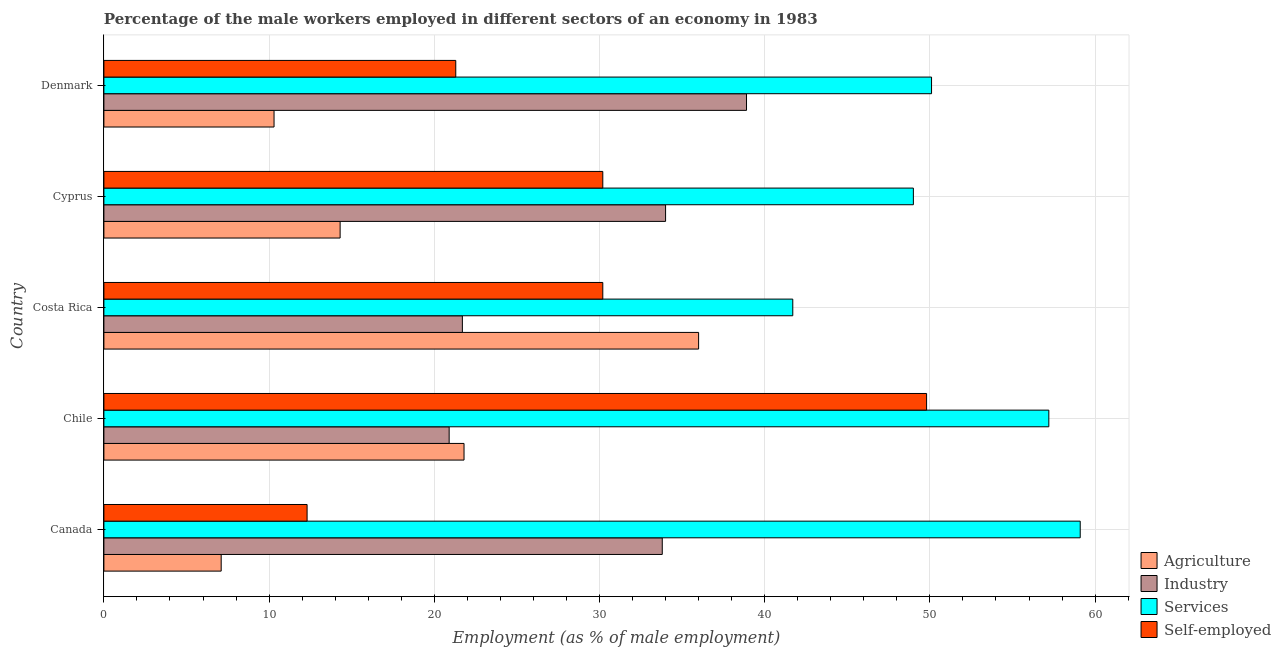How many different coloured bars are there?
Offer a terse response. 4. How many groups of bars are there?
Your answer should be compact. 5. Are the number of bars on each tick of the Y-axis equal?
Provide a short and direct response. Yes. How many bars are there on the 2nd tick from the bottom?
Provide a short and direct response. 4. What is the label of the 3rd group of bars from the top?
Offer a very short reply. Costa Rica. In how many cases, is the number of bars for a given country not equal to the number of legend labels?
Ensure brevity in your answer.  0. What is the percentage of male workers in industry in Chile?
Provide a short and direct response. 20.9. Across all countries, what is the maximum percentage of male workers in industry?
Offer a very short reply. 38.9. Across all countries, what is the minimum percentage of male workers in industry?
Offer a very short reply. 20.9. In which country was the percentage of male workers in industry minimum?
Your answer should be very brief. Chile. What is the total percentage of male workers in industry in the graph?
Provide a short and direct response. 149.3. What is the difference between the percentage of male workers in services in Costa Rica and that in Cyprus?
Keep it short and to the point. -7.3. What is the difference between the percentage of male workers in industry in Cyprus and the percentage of male workers in agriculture in Denmark?
Your answer should be very brief. 23.7. What is the average percentage of male workers in industry per country?
Offer a very short reply. 29.86. What is the difference between the percentage of male workers in industry and percentage of male workers in agriculture in Cyprus?
Offer a terse response. 19.7. In how many countries, is the percentage of male workers in agriculture greater than 4 %?
Provide a succinct answer. 5. What is the ratio of the percentage of male workers in services in Canada to that in Cyprus?
Offer a very short reply. 1.21. Is the percentage of male workers in agriculture in Canada less than that in Chile?
Offer a terse response. Yes. Is the difference between the percentage of self employed male workers in Costa Rica and Cyprus greater than the difference between the percentage of male workers in services in Costa Rica and Cyprus?
Offer a terse response. Yes. What is the difference between the highest and the lowest percentage of male workers in agriculture?
Give a very brief answer. 28.9. What does the 3rd bar from the top in Canada represents?
Your answer should be very brief. Industry. What does the 4th bar from the bottom in Cyprus represents?
Provide a succinct answer. Self-employed. Are all the bars in the graph horizontal?
Your answer should be very brief. Yes. What is the difference between two consecutive major ticks on the X-axis?
Provide a short and direct response. 10. Does the graph contain any zero values?
Your answer should be very brief. No. Where does the legend appear in the graph?
Keep it short and to the point. Bottom right. What is the title of the graph?
Your answer should be compact. Percentage of the male workers employed in different sectors of an economy in 1983. What is the label or title of the X-axis?
Your answer should be compact. Employment (as % of male employment). What is the Employment (as % of male employment) of Agriculture in Canada?
Provide a short and direct response. 7.1. What is the Employment (as % of male employment) of Industry in Canada?
Your response must be concise. 33.8. What is the Employment (as % of male employment) in Services in Canada?
Provide a succinct answer. 59.1. What is the Employment (as % of male employment) in Self-employed in Canada?
Keep it short and to the point. 12.3. What is the Employment (as % of male employment) of Agriculture in Chile?
Make the answer very short. 21.8. What is the Employment (as % of male employment) in Industry in Chile?
Offer a terse response. 20.9. What is the Employment (as % of male employment) of Services in Chile?
Your answer should be compact. 57.2. What is the Employment (as % of male employment) of Self-employed in Chile?
Your answer should be very brief. 49.8. What is the Employment (as % of male employment) in Agriculture in Costa Rica?
Your response must be concise. 36. What is the Employment (as % of male employment) in Industry in Costa Rica?
Your answer should be compact. 21.7. What is the Employment (as % of male employment) of Services in Costa Rica?
Ensure brevity in your answer.  41.7. What is the Employment (as % of male employment) of Self-employed in Costa Rica?
Your answer should be compact. 30.2. What is the Employment (as % of male employment) of Agriculture in Cyprus?
Your response must be concise. 14.3. What is the Employment (as % of male employment) in Industry in Cyprus?
Your answer should be compact. 34. What is the Employment (as % of male employment) of Services in Cyprus?
Your answer should be compact. 49. What is the Employment (as % of male employment) in Self-employed in Cyprus?
Provide a short and direct response. 30.2. What is the Employment (as % of male employment) in Agriculture in Denmark?
Keep it short and to the point. 10.3. What is the Employment (as % of male employment) in Industry in Denmark?
Your response must be concise. 38.9. What is the Employment (as % of male employment) in Services in Denmark?
Your answer should be compact. 50.1. What is the Employment (as % of male employment) in Self-employed in Denmark?
Your answer should be compact. 21.3. Across all countries, what is the maximum Employment (as % of male employment) in Agriculture?
Give a very brief answer. 36. Across all countries, what is the maximum Employment (as % of male employment) of Industry?
Ensure brevity in your answer.  38.9. Across all countries, what is the maximum Employment (as % of male employment) of Services?
Give a very brief answer. 59.1. Across all countries, what is the maximum Employment (as % of male employment) of Self-employed?
Offer a very short reply. 49.8. Across all countries, what is the minimum Employment (as % of male employment) of Agriculture?
Offer a very short reply. 7.1. Across all countries, what is the minimum Employment (as % of male employment) of Industry?
Provide a succinct answer. 20.9. Across all countries, what is the minimum Employment (as % of male employment) in Services?
Keep it short and to the point. 41.7. Across all countries, what is the minimum Employment (as % of male employment) of Self-employed?
Offer a terse response. 12.3. What is the total Employment (as % of male employment) of Agriculture in the graph?
Your answer should be compact. 89.5. What is the total Employment (as % of male employment) in Industry in the graph?
Provide a short and direct response. 149.3. What is the total Employment (as % of male employment) in Services in the graph?
Give a very brief answer. 257.1. What is the total Employment (as % of male employment) in Self-employed in the graph?
Make the answer very short. 143.8. What is the difference between the Employment (as % of male employment) of Agriculture in Canada and that in Chile?
Offer a terse response. -14.7. What is the difference between the Employment (as % of male employment) of Industry in Canada and that in Chile?
Offer a terse response. 12.9. What is the difference between the Employment (as % of male employment) in Services in Canada and that in Chile?
Offer a terse response. 1.9. What is the difference between the Employment (as % of male employment) in Self-employed in Canada and that in Chile?
Your answer should be very brief. -37.5. What is the difference between the Employment (as % of male employment) in Agriculture in Canada and that in Costa Rica?
Offer a very short reply. -28.9. What is the difference between the Employment (as % of male employment) of Industry in Canada and that in Costa Rica?
Make the answer very short. 12.1. What is the difference between the Employment (as % of male employment) in Self-employed in Canada and that in Costa Rica?
Make the answer very short. -17.9. What is the difference between the Employment (as % of male employment) of Agriculture in Canada and that in Cyprus?
Give a very brief answer. -7.2. What is the difference between the Employment (as % of male employment) in Services in Canada and that in Cyprus?
Your answer should be compact. 10.1. What is the difference between the Employment (as % of male employment) in Self-employed in Canada and that in Cyprus?
Your response must be concise. -17.9. What is the difference between the Employment (as % of male employment) in Agriculture in Canada and that in Denmark?
Your answer should be compact. -3.2. What is the difference between the Employment (as % of male employment) in Industry in Canada and that in Denmark?
Provide a succinct answer. -5.1. What is the difference between the Employment (as % of male employment) of Services in Canada and that in Denmark?
Offer a terse response. 9. What is the difference between the Employment (as % of male employment) of Self-employed in Canada and that in Denmark?
Your answer should be compact. -9. What is the difference between the Employment (as % of male employment) in Agriculture in Chile and that in Costa Rica?
Offer a terse response. -14.2. What is the difference between the Employment (as % of male employment) of Industry in Chile and that in Costa Rica?
Your answer should be compact. -0.8. What is the difference between the Employment (as % of male employment) of Services in Chile and that in Costa Rica?
Offer a very short reply. 15.5. What is the difference between the Employment (as % of male employment) of Self-employed in Chile and that in Costa Rica?
Give a very brief answer. 19.6. What is the difference between the Employment (as % of male employment) of Agriculture in Chile and that in Cyprus?
Your answer should be compact. 7.5. What is the difference between the Employment (as % of male employment) of Industry in Chile and that in Cyprus?
Offer a terse response. -13.1. What is the difference between the Employment (as % of male employment) in Self-employed in Chile and that in Cyprus?
Your answer should be compact. 19.6. What is the difference between the Employment (as % of male employment) in Agriculture in Chile and that in Denmark?
Ensure brevity in your answer.  11.5. What is the difference between the Employment (as % of male employment) in Services in Chile and that in Denmark?
Your response must be concise. 7.1. What is the difference between the Employment (as % of male employment) of Self-employed in Chile and that in Denmark?
Keep it short and to the point. 28.5. What is the difference between the Employment (as % of male employment) of Agriculture in Costa Rica and that in Cyprus?
Provide a short and direct response. 21.7. What is the difference between the Employment (as % of male employment) of Industry in Costa Rica and that in Cyprus?
Offer a very short reply. -12.3. What is the difference between the Employment (as % of male employment) in Services in Costa Rica and that in Cyprus?
Keep it short and to the point. -7.3. What is the difference between the Employment (as % of male employment) of Agriculture in Costa Rica and that in Denmark?
Offer a terse response. 25.7. What is the difference between the Employment (as % of male employment) in Industry in Costa Rica and that in Denmark?
Keep it short and to the point. -17.2. What is the difference between the Employment (as % of male employment) of Services in Costa Rica and that in Denmark?
Your response must be concise. -8.4. What is the difference between the Employment (as % of male employment) of Industry in Cyprus and that in Denmark?
Your answer should be very brief. -4.9. What is the difference between the Employment (as % of male employment) in Services in Cyprus and that in Denmark?
Your answer should be compact. -1.1. What is the difference between the Employment (as % of male employment) in Self-employed in Cyprus and that in Denmark?
Your answer should be very brief. 8.9. What is the difference between the Employment (as % of male employment) in Agriculture in Canada and the Employment (as % of male employment) in Services in Chile?
Your response must be concise. -50.1. What is the difference between the Employment (as % of male employment) in Agriculture in Canada and the Employment (as % of male employment) in Self-employed in Chile?
Your response must be concise. -42.7. What is the difference between the Employment (as % of male employment) in Industry in Canada and the Employment (as % of male employment) in Services in Chile?
Give a very brief answer. -23.4. What is the difference between the Employment (as % of male employment) in Industry in Canada and the Employment (as % of male employment) in Self-employed in Chile?
Your response must be concise. -16. What is the difference between the Employment (as % of male employment) in Agriculture in Canada and the Employment (as % of male employment) in Industry in Costa Rica?
Offer a very short reply. -14.6. What is the difference between the Employment (as % of male employment) in Agriculture in Canada and the Employment (as % of male employment) in Services in Costa Rica?
Your answer should be very brief. -34.6. What is the difference between the Employment (as % of male employment) in Agriculture in Canada and the Employment (as % of male employment) in Self-employed in Costa Rica?
Your answer should be compact. -23.1. What is the difference between the Employment (as % of male employment) of Services in Canada and the Employment (as % of male employment) of Self-employed in Costa Rica?
Ensure brevity in your answer.  28.9. What is the difference between the Employment (as % of male employment) of Agriculture in Canada and the Employment (as % of male employment) of Industry in Cyprus?
Give a very brief answer. -26.9. What is the difference between the Employment (as % of male employment) of Agriculture in Canada and the Employment (as % of male employment) of Services in Cyprus?
Provide a succinct answer. -41.9. What is the difference between the Employment (as % of male employment) of Agriculture in Canada and the Employment (as % of male employment) of Self-employed in Cyprus?
Your response must be concise. -23.1. What is the difference between the Employment (as % of male employment) of Industry in Canada and the Employment (as % of male employment) of Services in Cyprus?
Offer a very short reply. -15.2. What is the difference between the Employment (as % of male employment) in Industry in Canada and the Employment (as % of male employment) in Self-employed in Cyprus?
Offer a terse response. 3.6. What is the difference between the Employment (as % of male employment) in Services in Canada and the Employment (as % of male employment) in Self-employed in Cyprus?
Your response must be concise. 28.9. What is the difference between the Employment (as % of male employment) in Agriculture in Canada and the Employment (as % of male employment) in Industry in Denmark?
Your answer should be very brief. -31.8. What is the difference between the Employment (as % of male employment) of Agriculture in Canada and the Employment (as % of male employment) of Services in Denmark?
Ensure brevity in your answer.  -43. What is the difference between the Employment (as % of male employment) of Agriculture in Canada and the Employment (as % of male employment) of Self-employed in Denmark?
Ensure brevity in your answer.  -14.2. What is the difference between the Employment (as % of male employment) in Industry in Canada and the Employment (as % of male employment) in Services in Denmark?
Your answer should be very brief. -16.3. What is the difference between the Employment (as % of male employment) of Industry in Canada and the Employment (as % of male employment) of Self-employed in Denmark?
Provide a short and direct response. 12.5. What is the difference between the Employment (as % of male employment) in Services in Canada and the Employment (as % of male employment) in Self-employed in Denmark?
Provide a short and direct response. 37.8. What is the difference between the Employment (as % of male employment) in Agriculture in Chile and the Employment (as % of male employment) in Services in Costa Rica?
Your answer should be very brief. -19.9. What is the difference between the Employment (as % of male employment) of Industry in Chile and the Employment (as % of male employment) of Services in Costa Rica?
Give a very brief answer. -20.8. What is the difference between the Employment (as % of male employment) of Agriculture in Chile and the Employment (as % of male employment) of Services in Cyprus?
Your response must be concise. -27.2. What is the difference between the Employment (as % of male employment) in Industry in Chile and the Employment (as % of male employment) in Services in Cyprus?
Your answer should be compact. -28.1. What is the difference between the Employment (as % of male employment) in Industry in Chile and the Employment (as % of male employment) in Self-employed in Cyprus?
Offer a terse response. -9.3. What is the difference between the Employment (as % of male employment) in Agriculture in Chile and the Employment (as % of male employment) in Industry in Denmark?
Provide a succinct answer. -17.1. What is the difference between the Employment (as % of male employment) in Agriculture in Chile and the Employment (as % of male employment) in Services in Denmark?
Your answer should be compact. -28.3. What is the difference between the Employment (as % of male employment) in Industry in Chile and the Employment (as % of male employment) in Services in Denmark?
Offer a very short reply. -29.2. What is the difference between the Employment (as % of male employment) of Services in Chile and the Employment (as % of male employment) of Self-employed in Denmark?
Ensure brevity in your answer.  35.9. What is the difference between the Employment (as % of male employment) of Agriculture in Costa Rica and the Employment (as % of male employment) of Industry in Cyprus?
Your answer should be compact. 2. What is the difference between the Employment (as % of male employment) in Agriculture in Costa Rica and the Employment (as % of male employment) in Self-employed in Cyprus?
Keep it short and to the point. 5.8. What is the difference between the Employment (as % of male employment) in Industry in Costa Rica and the Employment (as % of male employment) in Services in Cyprus?
Your answer should be compact. -27.3. What is the difference between the Employment (as % of male employment) in Agriculture in Costa Rica and the Employment (as % of male employment) in Services in Denmark?
Give a very brief answer. -14.1. What is the difference between the Employment (as % of male employment) in Agriculture in Costa Rica and the Employment (as % of male employment) in Self-employed in Denmark?
Ensure brevity in your answer.  14.7. What is the difference between the Employment (as % of male employment) in Industry in Costa Rica and the Employment (as % of male employment) in Services in Denmark?
Give a very brief answer. -28.4. What is the difference between the Employment (as % of male employment) of Industry in Costa Rica and the Employment (as % of male employment) of Self-employed in Denmark?
Provide a succinct answer. 0.4. What is the difference between the Employment (as % of male employment) of Services in Costa Rica and the Employment (as % of male employment) of Self-employed in Denmark?
Make the answer very short. 20.4. What is the difference between the Employment (as % of male employment) of Agriculture in Cyprus and the Employment (as % of male employment) of Industry in Denmark?
Keep it short and to the point. -24.6. What is the difference between the Employment (as % of male employment) of Agriculture in Cyprus and the Employment (as % of male employment) of Services in Denmark?
Offer a terse response. -35.8. What is the difference between the Employment (as % of male employment) of Industry in Cyprus and the Employment (as % of male employment) of Services in Denmark?
Your answer should be compact. -16.1. What is the difference between the Employment (as % of male employment) in Services in Cyprus and the Employment (as % of male employment) in Self-employed in Denmark?
Provide a succinct answer. 27.7. What is the average Employment (as % of male employment) in Industry per country?
Make the answer very short. 29.86. What is the average Employment (as % of male employment) in Services per country?
Provide a succinct answer. 51.42. What is the average Employment (as % of male employment) in Self-employed per country?
Give a very brief answer. 28.76. What is the difference between the Employment (as % of male employment) of Agriculture and Employment (as % of male employment) of Industry in Canada?
Provide a short and direct response. -26.7. What is the difference between the Employment (as % of male employment) in Agriculture and Employment (as % of male employment) in Services in Canada?
Offer a terse response. -52. What is the difference between the Employment (as % of male employment) of Industry and Employment (as % of male employment) of Services in Canada?
Offer a terse response. -25.3. What is the difference between the Employment (as % of male employment) of Industry and Employment (as % of male employment) of Self-employed in Canada?
Give a very brief answer. 21.5. What is the difference between the Employment (as % of male employment) of Services and Employment (as % of male employment) of Self-employed in Canada?
Your response must be concise. 46.8. What is the difference between the Employment (as % of male employment) in Agriculture and Employment (as % of male employment) in Services in Chile?
Provide a short and direct response. -35.4. What is the difference between the Employment (as % of male employment) in Agriculture and Employment (as % of male employment) in Self-employed in Chile?
Make the answer very short. -28. What is the difference between the Employment (as % of male employment) in Industry and Employment (as % of male employment) in Services in Chile?
Give a very brief answer. -36.3. What is the difference between the Employment (as % of male employment) in Industry and Employment (as % of male employment) in Self-employed in Chile?
Your answer should be very brief. -28.9. What is the difference between the Employment (as % of male employment) of Services and Employment (as % of male employment) of Self-employed in Chile?
Your answer should be compact. 7.4. What is the difference between the Employment (as % of male employment) in Agriculture and Employment (as % of male employment) in Services in Costa Rica?
Offer a terse response. -5.7. What is the difference between the Employment (as % of male employment) in Agriculture and Employment (as % of male employment) in Self-employed in Costa Rica?
Your response must be concise. 5.8. What is the difference between the Employment (as % of male employment) in Industry and Employment (as % of male employment) in Services in Costa Rica?
Offer a terse response. -20. What is the difference between the Employment (as % of male employment) of Industry and Employment (as % of male employment) of Self-employed in Costa Rica?
Your answer should be compact. -8.5. What is the difference between the Employment (as % of male employment) in Services and Employment (as % of male employment) in Self-employed in Costa Rica?
Offer a terse response. 11.5. What is the difference between the Employment (as % of male employment) of Agriculture and Employment (as % of male employment) of Industry in Cyprus?
Offer a terse response. -19.7. What is the difference between the Employment (as % of male employment) in Agriculture and Employment (as % of male employment) in Services in Cyprus?
Your answer should be compact. -34.7. What is the difference between the Employment (as % of male employment) of Agriculture and Employment (as % of male employment) of Self-employed in Cyprus?
Your answer should be compact. -15.9. What is the difference between the Employment (as % of male employment) in Agriculture and Employment (as % of male employment) in Industry in Denmark?
Give a very brief answer. -28.6. What is the difference between the Employment (as % of male employment) of Agriculture and Employment (as % of male employment) of Services in Denmark?
Your answer should be very brief. -39.8. What is the difference between the Employment (as % of male employment) of Industry and Employment (as % of male employment) of Services in Denmark?
Keep it short and to the point. -11.2. What is the difference between the Employment (as % of male employment) of Industry and Employment (as % of male employment) of Self-employed in Denmark?
Offer a terse response. 17.6. What is the difference between the Employment (as % of male employment) of Services and Employment (as % of male employment) of Self-employed in Denmark?
Your answer should be compact. 28.8. What is the ratio of the Employment (as % of male employment) in Agriculture in Canada to that in Chile?
Your response must be concise. 0.33. What is the ratio of the Employment (as % of male employment) of Industry in Canada to that in Chile?
Give a very brief answer. 1.62. What is the ratio of the Employment (as % of male employment) in Services in Canada to that in Chile?
Provide a succinct answer. 1.03. What is the ratio of the Employment (as % of male employment) in Self-employed in Canada to that in Chile?
Ensure brevity in your answer.  0.25. What is the ratio of the Employment (as % of male employment) in Agriculture in Canada to that in Costa Rica?
Provide a short and direct response. 0.2. What is the ratio of the Employment (as % of male employment) in Industry in Canada to that in Costa Rica?
Provide a succinct answer. 1.56. What is the ratio of the Employment (as % of male employment) of Services in Canada to that in Costa Rica?
Provide a short and direct response. 1.42. What is the ratio of the Employment (as % of male employment) in Self-employed in Canada to that in Costa Rica?
Offer a very short reply. 0.41. What is the ratio of the Employment (as % of male employment) of Agriculture in Canada to that in Cyprus?
Your answer should be very brief. 0.5. What is the ratio of the Employment (as % of male employment) of Industry in Canada to that in Cyprus?
Provide a succinct answer. 0.99. What is the ratio of the Employment (as % of male employment) of Services in Canada to that in Cyprus?
Ensure brevity in your answer.  1.21. What is the ratio of the Employment (as % of male employment) in Self-employed in Canada to that in Cyprus?
Your answer should be compact. 0.41. What is the ratio of the Employment (as % of male employment) of Agriculture in Canada to that in Denmark?
Make the answer very short. 0.69. What is the ratio of the Employment (as % of male employment) of Industry in Canada to that in Denmark?
Make the answer very short. 0.87. What is the ratio of the Employment (as % of male employment) of Services in Canada to that in Denmark?
Provide a short and direct response. 1.18. What is the ratio of the Employment (as % of male employment) of Self-employed in Canada to that in Denmark?
Make the answer very short. 0.58. What is the ratio of the Employment (as % of male employment) of Agriculture in Chile to that in Costa Rica?
Keep it short and to the point. 0.61. What is the ratio of the Employment (as % of male employment) of Industry in Chile to that in Costa Rica?
Offer a terse response. 0.96. What is the ratio of the Employment (as % of male employment) of Services in Chile to that in Costa Rica?
Offer a very short reply. 1.37. What is the ratio of the Employment (as % of male employment) of Self-employed in Chile to that in Costa Rica?
Your response must be concise. 1.65. What is the ratio of the Employment (as % of male employment) of Agriculture in Chile to that in Cyprus?
Your answer should be very brief. 1.52. What is the ratio of the Employment (as % of male employment) of Industry in Chile to that in Cyprus?
Offer a very short reply. 0.61. What is the ratio of the Employment (as % of male employment) of Services in Chile to that in Cyprus?
Your answer should be compact. 1.17. What is the ratio of the Employment (as % of male employment) of Self-employed in Chile to that in Cyprus?
Provide a succinct answer. 1.65. What is the ratio of the Employment (as % of male employment) in Agriculture in Chile to that in Denmark?
Provide a succinct answer. 2.12. What is the ratio of the Employment (as % of male employment) in Industry in Chile to that in Denmark?
Make the answer very short. 0.54. What is the ratio of the Employment (as % of male employment) of Services in Chile to that in Denmark?
Offer a terse response. 1.14. What is the ratio of the Employment (as % of male employment) in Self-employed in Chile to that in Denmark?
Keep it short and to the point. 2.34. What is the ratio of the Employment (as % of male employment) of Agriculture in Costa Rica to that in Cyprus?
Provide a short and direct response. 2.52. What is the ratio of the Employment (as % of male employment) in Industry in Costa Rica to that in Cyprus?
Make the answer very short. 0.64. What is the ratio of the Employment (as % of male employment) of Services in Costa Rica to that in Cyprus?
Provide a succinct answer. 0.85. What is the ratio of the Employment (as % of male employment) in Self-employed in Costa Rica to that in Cyprus?
Offer a very short reply. 1. What is the ratio of the Employment (as % of male employment) of Agriculture in Costa Rica to that in Denmark?
Your answer should be very brief. 3.5. What is the ratio of the Employment (as % of male employment) in Industry in Costa Rica to that in Denmark?
Offer a very short reply. 0.56. What is the ratio of the Employment (as % of male employment) in Services in Costa Rica to that in Denmark?
Give a very brief answer. 0.83. What is the ratio of the Employment (as % of male employment) of Self-employed in Costa Rica to that in Denmark?
Provide a succinct answer. 1.42. What is the ratio of the Employment (as % of male employment) of Agriculture in Cyprus to that in Denmark?
Give a very brief answer. 1.39. What is the ratio of the Employment (as % of male employment) in Industry in Cyprus to that in Denmark?
Keep it short and to the point. 0.87. What is the ratio of the Employment (as % of male employment) in Services in Cyprus to that in Denmark?
Your answer should be compact. 0.98. What is the ratio of the Employment (as % of male employment) of Self-employed in Cyprus to that in Denmark?
Give a very brief answer. 1.42. What is the difference between the highest and the second highest Employment (as % of male employment) of Services?
Provide a succinct answer. 1.9. What is the difference between the highest and the second highest Employment (as % of male employment) in Self-employed?
Make the answer very short. 19.6. What is the difference between the highest and the lowest Employment (as % of male employment) in Agriculture?
Your answer should be very brief. 28.9. What is the difference between the highest and the lowest Employment (as % of male employment) of Industry?
Keep it short and to the point. 18. What is the difference between the highest and the lowest Employment (as % of male employment) of Self-employed?
Ensure brevity in your answer.  37.5. 